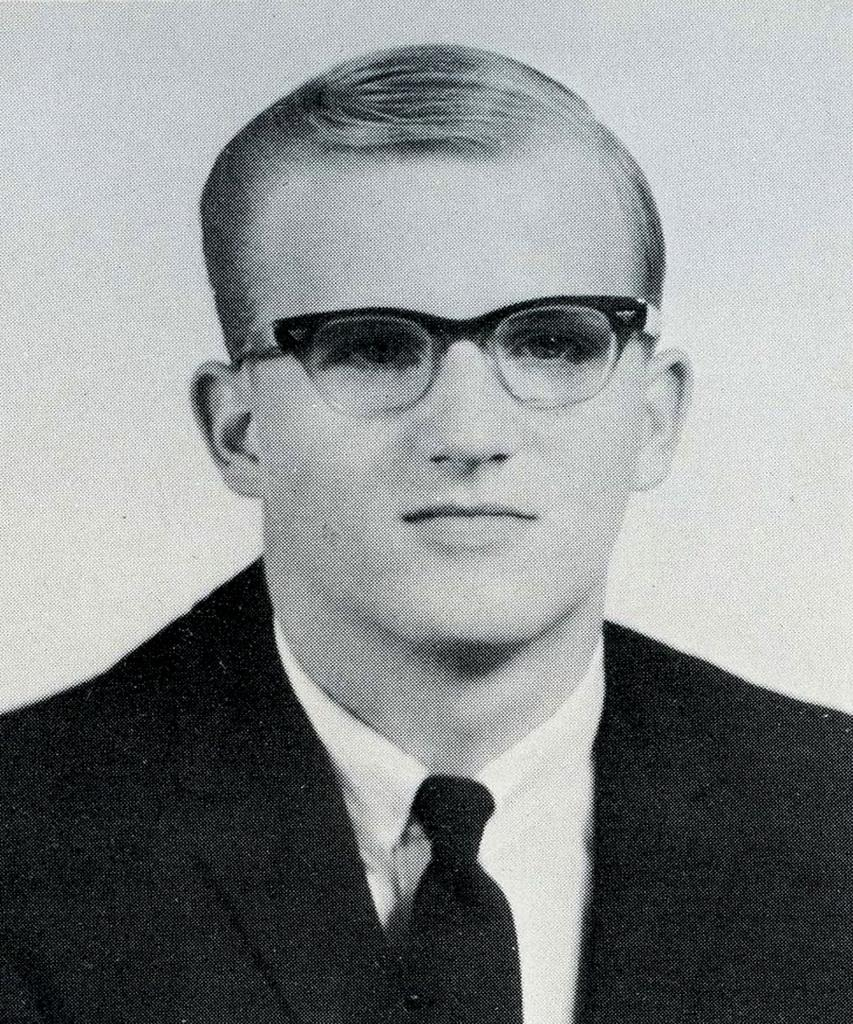What is the color scheme of the image? The image is black and white. Who is present in the image? There is a man in the image. What is the man wearing? The man is wearing a blazer, a tie, and spectacles. What is the man's facial expression? The man is smiling. Can you see a fight happening between the man and a frog in the image? There is no fight or frog present in the image; it features a man wearing a blazer, tie, and spectacles while smiling. 